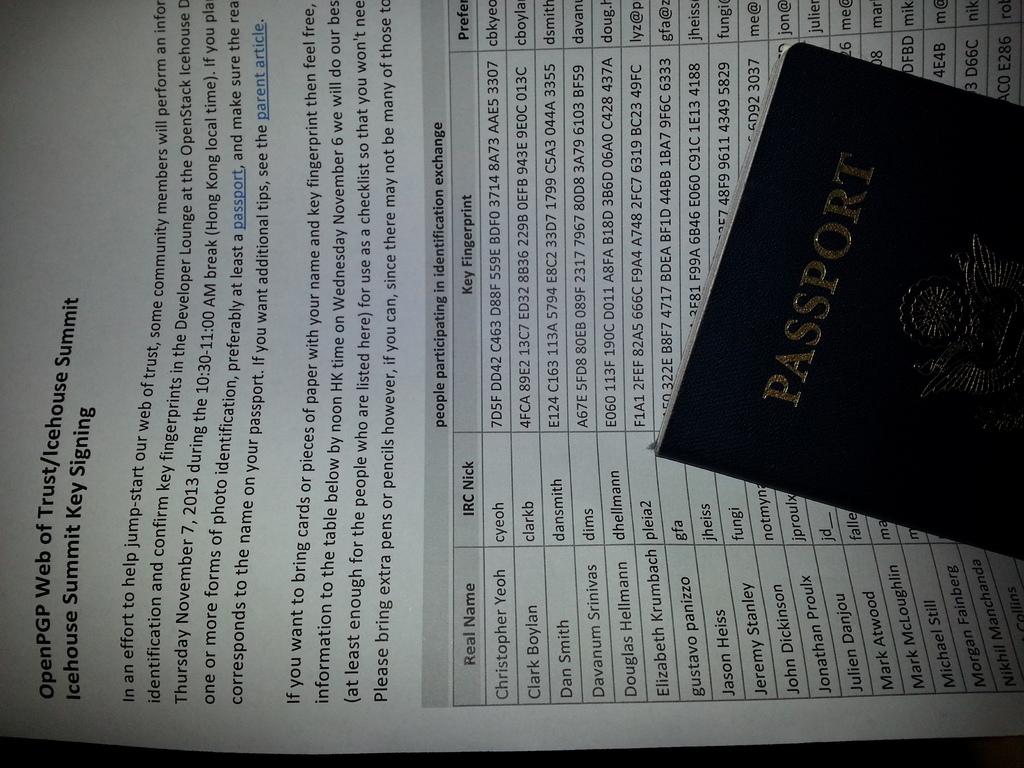What is the first real name listed?
Give a very brief answer. Christopher yeoh. 